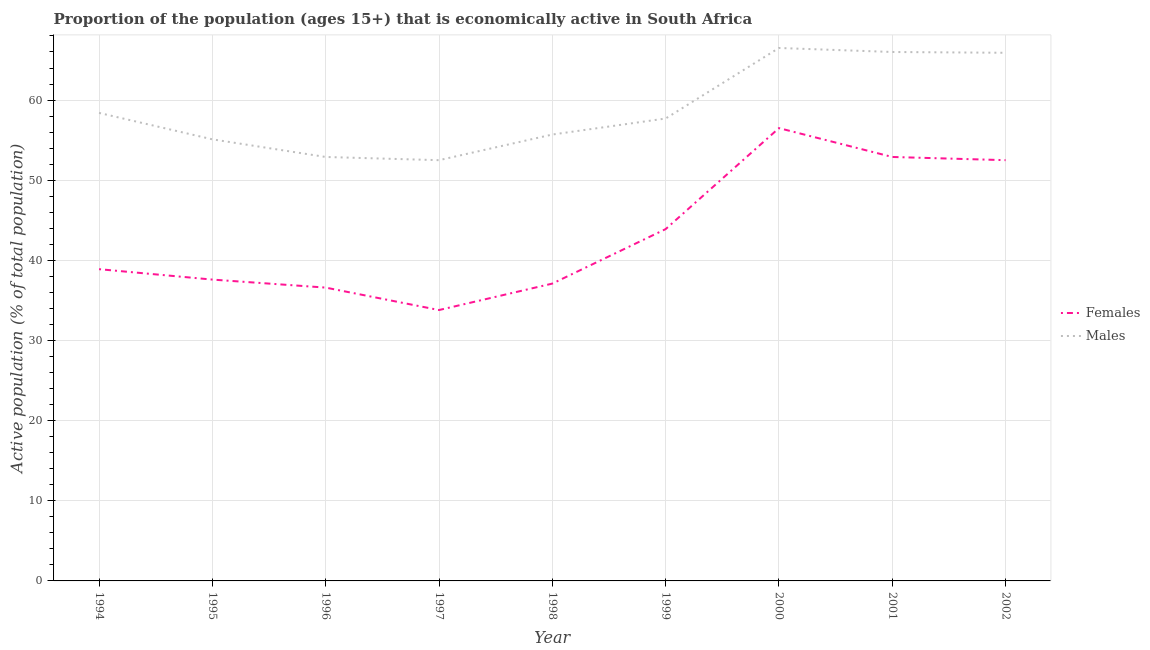Does the line corresponding to percentage of economically active male population intersect with the line corresponding to percentage of economically active female population?
Give a very brief answer. No. What is the percentage of economically active female population in 2002?
Your response must be concise. 52.5. Across all years, what is the maximum percentage of economically active male population?
Make the answer very short. 66.5. Across all years, what is the minimum percentage of economically active male population?
Offer a terse response. 52.5. In which year was the percentage of economically active female population maximum?
Your response must be concise. 2000. In which year was the percentage of economically active male population minimum?
Provide a succinct answer. 1997. What is the total percentage of economically active female population in the graph?
Your answer should be compact. 389.8. What is the difference between the percentage of economically active female population in 1998 and that in 1999?
Ensure brevity in your answer.  -6.8. What is the average percentage of economically active male population per year?
Keep it short and to the point. 58.97. In the year 2000, what is the difference between the percentage of economically active male population and percentage of economically active female population?
Make the answer very short. 10. What is the ratio of the percentage of economically active female population in 1994 to that in 2002?
Make the answer very short. 0.74. What is the difference between the highest and the second highest percentage of economically active female population?
Keep it short and to the point. 3.6. What is the difference between the highest and the lowest percentage of economically active male population?
Your answer should be very brief. 14. In how many years, is the percentage of economically active female population greater than the average percentage of economically active female population taken over all years?
Keep it short and to the point. 4. Are the values on the major ticks of Y-axis written in scientific E-notation?
Ensure brevity in your answer.  No. Does the graph contain any zero values?
Keep it short and to the point. No. Does the graph contain grids?
Your response must be concise. Yes. How many legend labels are there?
Provide a short and direct response. 2. What is the title of the graph?
Provide a short and direct response. Proportion of the population (ages 15+) that is economically active in South Africa. Does "Education" appear as one of the legend labels in the graph?
Keep it short and to the point. No. What is the label or title of the Y-axis?
Make the answer very short. Active population (% of total population). What is the Active population (% of total population) of Females in 1994?
Offer a terse response. 38.9. What is the Active population (% of total population) in Males in 1994?
Offer a terse response. 58.4. What is the Active population (% of total population) in Females in 1995?
Provide a succinct answer. 37.6. What is the Active population (% of total population) in Males in 1995?
Provide a short and direct response. 55.1. What is the Active population (% of total population) of Females in 1996?
Give a very brief answer. 36.6. What is the Active population (% of total population) in Males in 1996?
Ensure brevity in your answer.  52.9. What is the Active population (% of total population) in Females in 1997?
Your answer should be compact. 33.8. What is the Active population (% of total population) in Males in 1997?
Ensure brevity in your answer.  52.5. What is the Active population (% of total population) in Females in 1998?
Your answer should be compact. 37.1. What is the Active population (% of total population) in Males in 1998?
Offer a very short reply. 55.7. What is the Active population (% of total population) in Females in 1999?
Keep it short and to the point. 43.9. What is the Active population (% of total population) in Males in 1999?
Give a very brief answer. 57.7. What is the Active population (% of total population) in Females in 2000?
Your answer should be compact. 56.5. What is the Active population (% of total population) in Males in 2000?
Your answer should be compact. 66.5. What is the Active population (% of total population) in Females in 2001?
Keep it short and to the point. 52.9. What is the Active population (% of total population) in Females in 2002?
Keep it short and to the point. 52.5. What is the Active population (% of total population) of Males in 2002?
Make the answer very short. 65.9. Across all years, what is the maximum Active population (% of total population) in Females?
Your answer should be very brief. 56.5. Across all years, what is the maximum Active population (% of total population) of Males?
Make the answer very short. 66.5. Across all years, what is the minimum Active population (% of total population) in Females?
Make the answer very short. 33.8. Across all years, what is the minimum Active population (% of total population) in Males?
Keep it short and to the point. 52.5. What is the total Active population (% of total population) in Females in the graph?
Give a very brief answer. 389.8. What is the total Active population (% of total population) of Males in the graph?
Keep it short and to the point. 530.7. What is the difference between the Active population (% of total population) of Females in 1994 and that in 1997?
Keep it short and to the point. 5.1. What is the difference between the Active population (% of total population) of Females in 1994 and that in 1998?
Offer a terse response. 1.8. What is the difference between the Active population (% of total population) in Males in 1994 and that in 1998?
Make the answer very short. 2.7. What is the difference between the Active population (% of total population) in Females in 1994 and that in 1999?
Give a very brief answer. -5. What is the difference between the Active population (% of total population) of Males in 1994 and that in 1999?
Give a very brief answer. 0.7. What is the difference between the Active population (% of total population) of Females in 1994 and that in 2000?
Provide a short and direct response. -17.6. What is the difference between the Active population (% of total population) of Males in 1994 and that in 2000?
Make the answer very short. -8.1. What is the difference between the Active population (% of total population) in Females in 1994 and that in 2002?
Offer a terse response. -13.6. What is the difference between the Active population (% of total population) in Females in 1995 and that in 1996?
Make the answer very short. 1. What is the difference between the Active population (% of total population) in Males in 1995 and that in 1996?
Provide a succinct answer. 2.2. What is the difference between the Active population (% of total population) in Females in 1995 and that in 1997?
Make the answer very short. 3.8. What is the difference between the Active population (% of total population) of Females in 1995 and that in 1998?
Give a very brief answer. 0.5. What is the difference between the Active population (% of total population) of Males in 1995 and that in 1999?
Your answer should be very brief. -2.6. What is the difference between the Active population (% of total population) of Females in 1995 and that in 2000?
Ensure brevity in your answer.  -18.9. What is the difference between the Active population (% of total population) of Males in 1995 and that in 2000?
Your answer should be very brief. -11.4. What is the difference between the Active population (% of total population) of Females in 1995 and that in 2001?
Your response must be concise. -15.3. What is the difference between the Active population (% of total population) in Males in 1995 and that in 2001?
Provide a succinct answer. -10.9. What is the difference between the Active population (% of total population) of Females in 1995 and that in 2002?
Give a very brief answer. -14.9. What is the difference between the Active population (% of total population) in Females in 1996 and that in 1998?
Your answer should be compact. -0.5. What is the difference between the Active population (% of total population) in Males in 1996 and that in 1998?
Provide a short and direct response. -2.8. What is the difference between the Active population (% of total population) in Males in 1996 and that in 1999?
Your response must be concise. -4.8. What is the difference between the Active population (% of total population) of Females in 1996 and that in 2000?
Your response must be concise. -19.9. What is the difference between the Active population (% of total population) in Males in 1996 and that in 2000?
Give a very brief answer. -13.6. What is the difference between the Active population (% of total population) of Females in 1996 and that in 2001?
Your answer should be compact. -16.3. What is the difference between the Active population (% of total population) of Males in 1996 and that in 2001?
Give a very brief answer. -13.1. What is the difference between the Active population (% of total population) in Females in 1996 and that in 2002?
Your answer should be very brief. -15.9. What is the difference between the Active population (% of total population) of Males in 1997 and that in 1998?
Ensure brevity in your answer.  -3.2. What is the difference between the Active population (% of total population) in Males in 1997 and that in 1999?
Keep it short and to the point. -5.2. What is the difference between the Active population (% of total population) in Females in 1997 and that in 2000?
Your answer should be compact. -22.7. What is the difference between the Active population (% of total population) in Males in 1997 and that in 2000?
Your response must be concise. -14. What is the difference between the Active population (% of total population) in Females in 1997 and that in 2001?
Provide a short and direct response. -19.1. What is the difference between the Active population (% of total population) in Males in 1997 and that in 2001?
Offer a very short reply. -13.5. What is the difference between the Active population (% of total population) in Females in 1997 and that in 2002?
Provide a short and direct response. -18.7. What is the difference between the Active population (% of total population) in Males in 1997 and that in 2002?
Ensure brevity in your answer.  -13.4. What is the difference between the Active population (% of total population) in Females in 1998 and that in 1999?
Ensure brevity in your answer.  -6.8. What is the difference between the Active population (% of total population) of Females in 1998 and that in 2000?
Provide a succinct answer. -19.4. What is the difference between the Active population (% of total population) in Males in 1998 and that in 2000?
Make the answer very short. -10.8. What is the difference between the Active population (% of total population) of Females in 1998 and that in 2001?
Provide a short and direct response. -15.8. What is the difference between the Active population (% of total population) in Males in 1998 and that in 2001?
Keep it short and to the point. -10.3. What is the difference between the Active population (% of total population) in Females in 1998 and that in 2002?
Your response must be concise. -15.4. What is the difference between the Active population (% of total population) in Females in 1999 and that in 2000?
Offer a very short reply. -12.6. What is the difference between the Active population (% of total population) of Females in 1999 and that in 2001?
Your answer should be compact. -9. What is the difference between the Active population (% of total population) in Males in 1999 and that in 2002?
Provide a succinct answer. -8.2. What is the difference between the Active population (% of total population) of Females in 2000 and that in 2001?
Ensure brevity in your answer.  3.6. What is the difference between the Active population (% of total population) in Males in 2001 and that in 2002?
Provide a succinct answer. 0.1. What is the difference between the Active population (% of total population) of Females in 1994 and the Active population (% of total population) of Males in 1995?
Your answer should be compact. -16.2. What is the difference between the Active population (% of total population) in Females in 1994 and the Active population (% of total population) in Males in 1998?
Provide a succinct answer. -16.8. What is the difference between the Active population (% of total population) in Females in 1994 and the Active population (% of total population) in Males in 1999?
Provide a short and direct response. -18.8. What is the difference between the Active population (% of total population) in Females in 1994 and the Active population (% of total population) in Males in 2000?
Offer a very short reply. -27.6. What is the difference between the Active population (% of total population) of Females in 1994 and the Active population (% of total population) of Males in 2001?
Provide a short and direct response. -27.1. What is the difference between the Active population (% of total population) of Females in 1994 and the Active population (% of total population) of Males in 2002?
Your answer should be very brief. -27. What is the difference between the Active population (% of total population) in Females in 1995 and the Active population (% of total population) in Males in 1996?
Ensure brevity in your answer.  -15.3. What is the difference between the Active population (% of total population) of Females in 1995 and the Active population (% of total population) of Males in 1997?
Ensure brevity in your answer.  -14.9. What is the difference between the Active population (% of total population) of Females in 1995 and the Active population (% of total population) of Males in 1998?
Offer a terse response. -18.1. What is the difference between the Active population (% of total population) of Females in 1995 and the Active population (% of total population) of Males in 1999?
Your answer should be very brief. -20.1. What is the difference between the Active population (% of total population) of Females in 1995 and the Active population (% of total population) of Males in 2000?
Keep it short and to the point. -28.9. What is the difference between the Active population (% of total population) in Females in 1995 and the Active population (% of total population) in Males in 2001?
Your response must be concise. -28.4. What is the difference between the Active population (% of total population) in Females in 1995 and the Active population (% of total population) in Males in 2002?
Your response must be concise. -28.3. What is the difference between the Active population (% of total population) in Females in 1996 and the Active population (% of total population) in Males in 1997?
Offer a very short reply. -15.9. What is the difference between the Active population (% of total population) in Females in 1996 and the Active population (% of total population) in Males in 1998?
Offer a very short reply. -19.1. What is the difference between the Active population (% of total population) in Females in 1996 and the Active population (% of total population) in Males in 1999?
Offer a terse response. -21.1. What is the difference between the Active population (% of total population) of Females in 1996 and the Active population (% of total population) of Males in 2000?
Your answer should be compact. -29.9. What is the difference between the Active population (% of total population) of Females in 1996 and the Active population (% of total population) of Males in 2001?
Provide a short and direct response. -29.4. What is the difference between the Active population (% of total population) of Females in 1996 and the Active population (% of total population) of Males in 2002?
Keep it short and to the point. -29.3. What is the difference between the Active population (% of total population) of Females in 1997 and the Active population (% of total population) of Males in 1998?
Give a very brief answer. -21.9. What is the difference between the Active population (% of total population) of Females in 1997 and the Active population (% of total population) of Males in 1999?
Ensure brevity in your answer.  -23.9. What is the difference between the Active population (% of total population) of Females in 1997 and the Active population (% of total population) of Males in 2000?
Provide a short and direct response. -32.7. What is the difference between the Active population (% of total population) in Females in 1997 and the Active population (% of total population) in Males in 2001?
Your answer should be very brief. -32.2. What is the difference between the Active population (% of total population) of Females in 1997 and the Active population (% of total population) of Males in 2002?
Give a very brief answer. -32.1. What is the difference between the Active population (% of total population) of Females in 1998 and the Active population (% of total population) of Males in 1999?
Keep it short and to the point. -20.6. What is the difference between the Active population (% of total population) of Females in 1998 and the Active population (% of total population) of Males in 2000?
Keep it short and to the point. -29.4. What is the difference between the Active population (% of total population) in Females in 1998 and the Active population (% of total population) in Males in 2001?
Provide a short and direct response. -28.9. What is the difference between the Active population (% of total population) in Females in 1998 and the Active population (% of total population) in Males in 2002?
Offer a very short reply. -28.8. What is the difference between the Active population (% of total population) of Females in 1999 and the Active population (% of total population) of Males in 2000?
Offer a terse response. -22.6. What is the difference between the Active population (% of total population) of Females in 1999 and the Active population (% of total population) of Males in 2001?
Keep it short and to the point. -22.1. What is the difference between the Active population (% of total population) in Females in 2000 and the Active population (% of total population) in Males in 2001?
Give a very brief answer. -9.5. What is the average Active population (% of total population) of Females per year?
Provide a succinct answer. 43.31. What is the average Active population (% of total population) in Males per year?
Offer a terse response. 58.97. In the year 1994, what is the difference between the Active population (% of total population) of Females and Active population (% of total population) of Males?
Your response must be concise. -19.5. In the year 1995, what is the difference between the Active population (% of total population) of Females and Active population (% of total population) of Males?
Your answer should be compact. -17.5. In the year 1996, what is the difference between the Active population (% of total population) in Females and Active population (% of total population) in Males?
Your answer should be compact. -16.3. In the year 1997, what is the difference between the Active population (% of total population) of Females and Active population (% of total population) of Males?
Your answer should be compact. -18.7. In the year 1998, what is the difference between the Active population (% of total population) of Females and Active population (% of total population) of Males?
Offer a very short reply. -18.6. In the year 2000, what is the difference between the Active population (% of total population) of Females and Active population (% of total population) of Males?
Your response must be concise. -10. What is the ratio of the Active population (% of total population) of Females in 1994 to that in 1995?
Provide a short and direct response. 1.03. What is the ratio of the Active population (% of total population) of Males in 1994 to that in 1995?
Offer a terse response. 1.06. What is the ratio of the Active population (% of total population) in Females in 1994 to that in 1996?
Your answer should be very brief. 1.06. What is the ratio of the Active population (% of total population) in Males in 1994 to that in 1996?
Your answer should be very brief. 1.1. What is the ratio of the Active population (% of total population) of Females in 1994 to that in 1997?
Keep it short and to the point. 1.15. What is the ratio of the Active population (% of total population) in Males in 1994 to that in 1997?
Your response must be concise. 1.11. What is the ratio of the Active population (% of total population) in Females in 1994 to that in 1998?
Your response must be concise. 1.05. What is the ratio of the Active population (% of total population) in Males in 1994 to that in 1998?
Provide a short and direct response. 1.05. What is the ratio of the Active population (% of total population) of Females in 1994 to that in 1999?
Ensure brevity in your answer.  0.89. What is the ratio of the Active population (% of total population) of Males in 1994 to that in 1999?
Keep it short and to the point. 1.01. What is the ratio of the Active population (% of total population) of Females in 1994 to that in 2000?
Ensure brevity in your answer.  0.69. What is the ratio of the Active population (% of total population) of Males in 1994 to that in 2000?
Provide a succinct answer. 0.88. What is the ratio of the Active population (% of total population) of Females in 1994 to that in 2001?
Provide a short and direct response. 0.74. What is the ratio of the Active population (% of total population) of Males in 1994 to that in 2001?
Make the answer very short. 0.88. What is the ratio of the Active population (% of total population) in Females in 1994 to that in 2002?
Offer a very short reply. 0.74. What is the ratio of the Active population (% of total population) of Males in 1994 to that in 2002?
Offer a very short reply. 0.89. What is the ratio of the Active population (% of total population) in Females in 1995 to that in 1996?
Your answer should be compact. 1.03. What is the ratio of the Active population (% of total population) of Males in 1995 to that in 1996?
Your answer should be very brief. 1.04. What is the ratio of the Active population (% of total population) of Females in 1995 to that in 1997?
Your response must be concise. 1.11. What is the ratio of the Active population (% of total population) of Males in 1995 to that in 1997?
Offer a terse response. 1.05. What is the ratio of the Active population (% of total population) in Females in 1995 to that in 1998?
Give a very brief answer. 1.01. What is the ratio of the Active population (% of total population) in Females in 1995 to that in 1999?
Make the answer very short. 0.86. What is the ratio of the Active population (% of total population) of Males in 1995 to that in 1999?
Your answer should be very brief. 0.95. What is the ratio of the Active population (% of total population) in Females in 1995 to that in 2000?
Offer a very short reply. 0.67. What is the ratio of the Active population (% of total population) of Males in 1995 to that in 2000?
Ensure brevity in your answer.  0.83. What is the ratio of the Active population (% of total population) in Females in 1995 to that in 2001?
Offer a very short reply. 0.71. What is the ratio of the Active population (% of total population) in Males in 1995 to that in 2001?
Ensure brevity in your answer.  0.83. What is the ratio of the Active population (% of total population) in Females in 1995 to that in 2002?
Offer a very short reply. 0.72. What is the ratio of the Active population (% of total population) in Males in 1995 to that in 2002?
Your answer should be compact. 0.84. What is the ratio of the Active population (% of total population) in Females in 1996 to that in 1997?
Your answer should be compact. 1.08. What is the ratio of the Active population (% of total population) in Males in 1996 to that in 1997?
Make the answer very short. 1.01. What is the ratio of the Active population (% of total population) of Females in 1996 to that in 1998?
Offer a very short reply. 0.99. What is the ratio of the Active population (% of total population) of Males in 1996 to that in 1998?
Ensure brevity in your answer.  0.95. What is the ratio of the Active population (% of total population) in Females in 1996 to that in 1999?
Give a very brief answer. 0.83. What is the ratio of the Active population (% of total population) in Males in 1996 to that in 1999?
Your answer should be compact. 0.92. What is the ratio of the Active population (% of total population) of Females in 1996 to that in 2000?
Provide a succinct answer. 0.65. What is the ratio of the Active population (% of total population) of Males in 1996 to that in 2000?
Offer a very short reply. 0.8. What is the ratio of the Active population (% of total population) of Females in 1996 to that in 2001?
Provide a succinct answer. 0.69. What is the ratio of the Active population (% of total population) in Males in 1996 to that in 2001?
Offer a terse response. 0.8. What is the ratio of the Active population (% of total population) in Females in 1996 to that in 2002?
Provide a short and direct response. 0.7. What is the ratio of the Active population (% of total population) of Males in 1996 to that in 2002?
Give a very brief answer. 0.8. What is the ratio of the Active population (% of total population) in Females in 1997 to that in 1998?
Provide a short and direct response. 0.91. What is the ratio of the Active population (% of total population) in Males in 1997 to that in 1998?
Make the answer very short. 0.94. What is the ratio of the Active population (% of total population) of Females in 1997 to that in 1999?
Provide a succinct answer. 0.77. What is the ratio of the Active population (% of total population) of Males in 1997 to that in 1999?
Give a very brief answer. 0.91. What is the ratio of the Active population (% of total population) of Females in 1997 to that in 2000?
Ensure brevity in your answer.  0.6. What is the ratio of the Active population (% of total population) of Males in 1997 to that in 2000?
Ensure brevity in your answer.  0.79. What is the ratio of the Active population (% of total population) of Females in 1997 to that in 2001?
Ensure brevity in your answer.  0.64. What is the ratio of the Active population (% of total population) of Males in 1997 to that in 2001?
Give a very brief answer. 0.8. What is the ratio of the Active population (% of total population) of Females in 1997 to that in 2002?
Provide a succinct answer. 0.64. What is the ratio of the Active population (% of total population) in Males in 1997 to that in 2002?
Your answer should be very brief. 0.8. What is the ratio of the Active population (% of total population) in Females in 1998 to that in 1999?
Your answer should be very brief. 0.85. What is the ratio of the Active population (% of total population) of Males in 1998 to that in 1999?
Give a very brief answer. 0.97. What is the ratio of the Active population (% of total population) in Females in 1998 to that in 2000?
Make the answer very short. 0.66. What is the ratio of the Active population (% of total population) of Males in 1998 to that in 2000?
Keep it short and to the point. 0.84. What is the ratio of the Active population (% of total population) of Females in 1998 to that in 2001?
Your answer should be very brief. 0.7. What is the ratio of the Active population (% of total population) in Males in 1998 to that in 2001?
Your response must be concise. 0.84. What is the ratio of the Active population (% of total population) in Females in 1998 to that in 2002?
Your answer should be very brief. 0.71. What is the ratio of the Active population (% of total population) of Males in 1998 to that in 2002?
Provide a succinct answer. 0.85. What is the ratio of the Active population (% of total population) of Females in 1999 to that in 2000?
Make the answer very short. 0.78. What is the ratio of the Active population (% of total population) in Males in 1999 to that in 2000?
Offer a terse response. 0.87. What is the ratio of the Active population (% of total population) of Females in 1999 to that in 2001?
Ensure brevity in your answer.  0.83. What is the ratio of the Active population (% of total population) of Males in 1999 to that in 2001?
Offer a terse response. 0.87. What is the ratio of the Active population (% of total population) of Females in 1999 to that in 2002?
Provide a short and direct response. 0.84. What is the ratio of the Active population (% of total population) in Males in 1999 to that in 2002?
Offer a very short reply. 0.88. What is the ratio of the Active population (% of total population) of Females in 2000 to that in 2001?
Offer a very short reply. 1.07. What is the ratio of the Active population (% of total population) of Males in 2000 to that in 2001?
Offer a very short reply. 1.01. What is the ratio of the Active population (% of total population) in Females in 2000 to that in 2002?
Offer a very short reply. 1.08. What is the ratio of the Active population (% of total population) of Males in 2000 to that in 2002?
Offer a very short reply. 1.01. What is the ratio of the Active population (% of total population) in Females in 2001 to that in 2002?
Provide a short and direct response. 1.01. What is the ratio of the Active population (% of total population) of Males in 2001 to that in 2002?
Make the answer very short. 1. What is the difference between the highest and the lowest Active population (% of total population) in Females?
Your response must be concise. 22.7. 